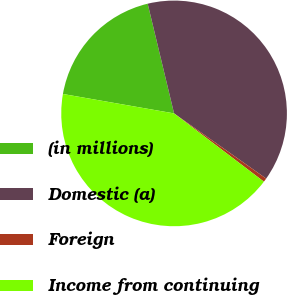<chart> <loc_0><loc_0><loc_500><loc_500><pie_chart><fcel>(in millions)<fcel>Domestic (a)<fcel>Foreign<fcel>Income from continuing<nl><fcel>18.49%<fcel>38.56%<fcel>0.54%<fcel>42.41%<nl></chart> 